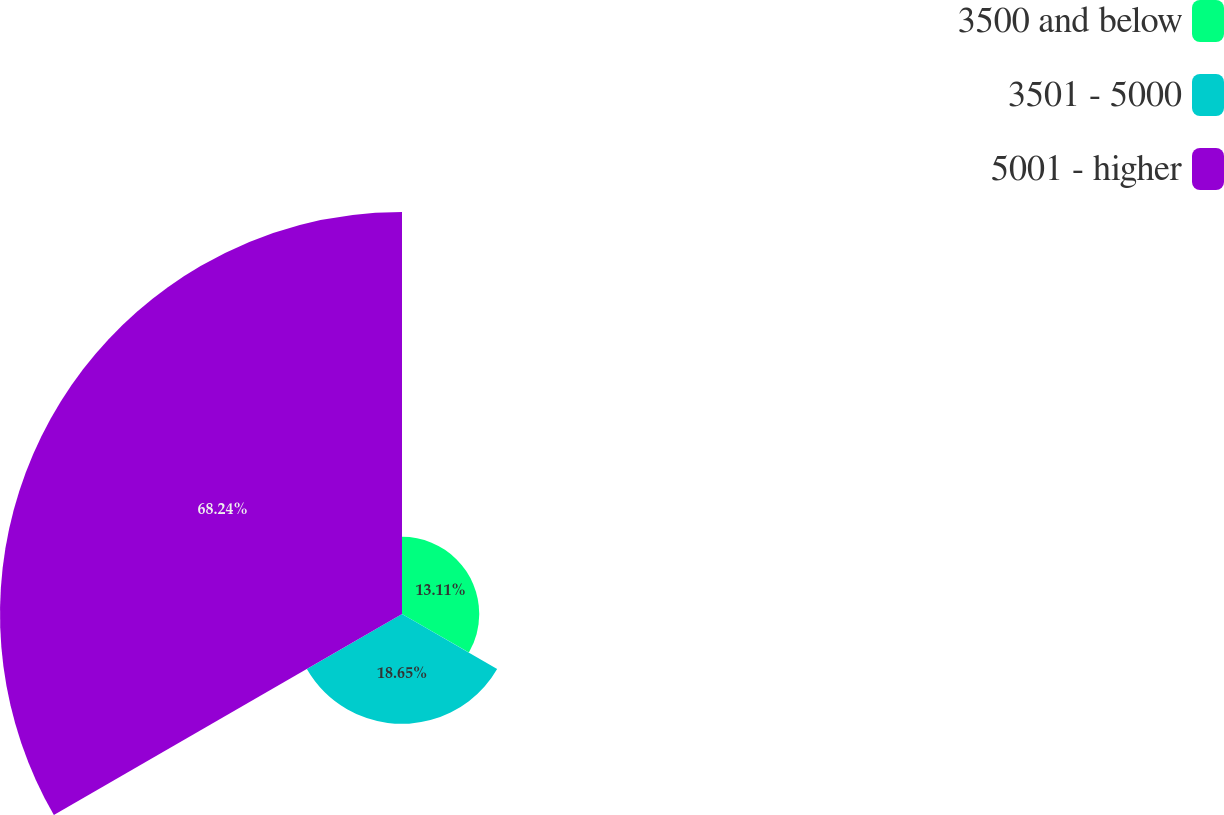Convert chart to OTSL. <chart><loc_0><loc_0><loc_500><loc_500><pie_chart><fcel>3500 and below<fcel>3501 - 5000<fcel>5001 - higher<nl><fcel>13.11%<fcel>18.65%<fcel>68.24%<nl></chart> 